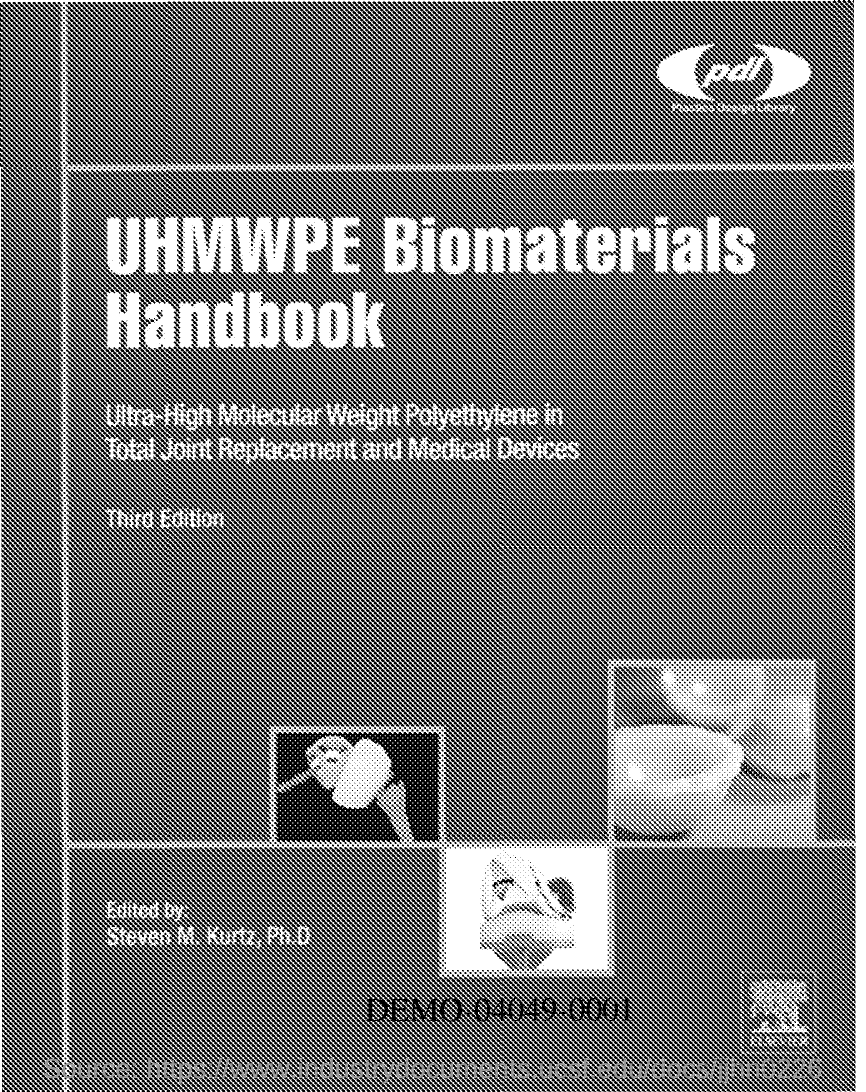Identify some key points in this picture. The name of the Handbook is the UHMWPE BIOMATERIALS HANDBOOK. 